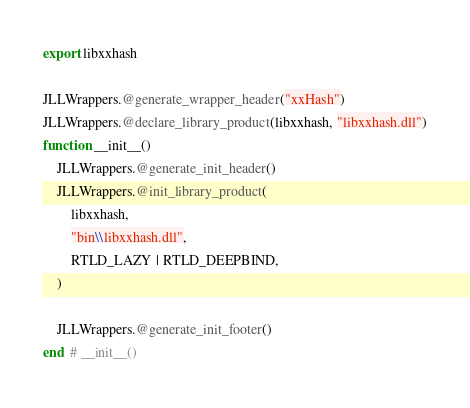<code> <loc_0><loc_0><loc_500><loc_500><_Julia_>export libxxhash

JLLWrappers.@generate_wrapper_header("xxHash")
JLLWrappers.@declare_library_product(libxxhash, "libxxhash.dll")
function __init__()
    JLLWrappers.@generate_init_header()
    JLLWrappers.@init_library_product(
        libxxhash,
        "bin\\libxxhash.dll",
        RTLD_LAZY | RTLD_DEEPBIND,
    )

    JLLWrappers.@generate_init_footer()
end  # __init__()
</code> 